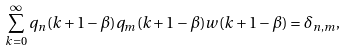Convert formula to latex. <formula><loc_0><loc_0><loc_500><loc_500>\sum _ { k = 0 } ^ { \infty } q _ { n } ( k + 1 - \beta ) q _ { m } ( k + 1 - \beta ) w ( k + 1 - \beta ) = \delta _ { n , m } ,</formula> 